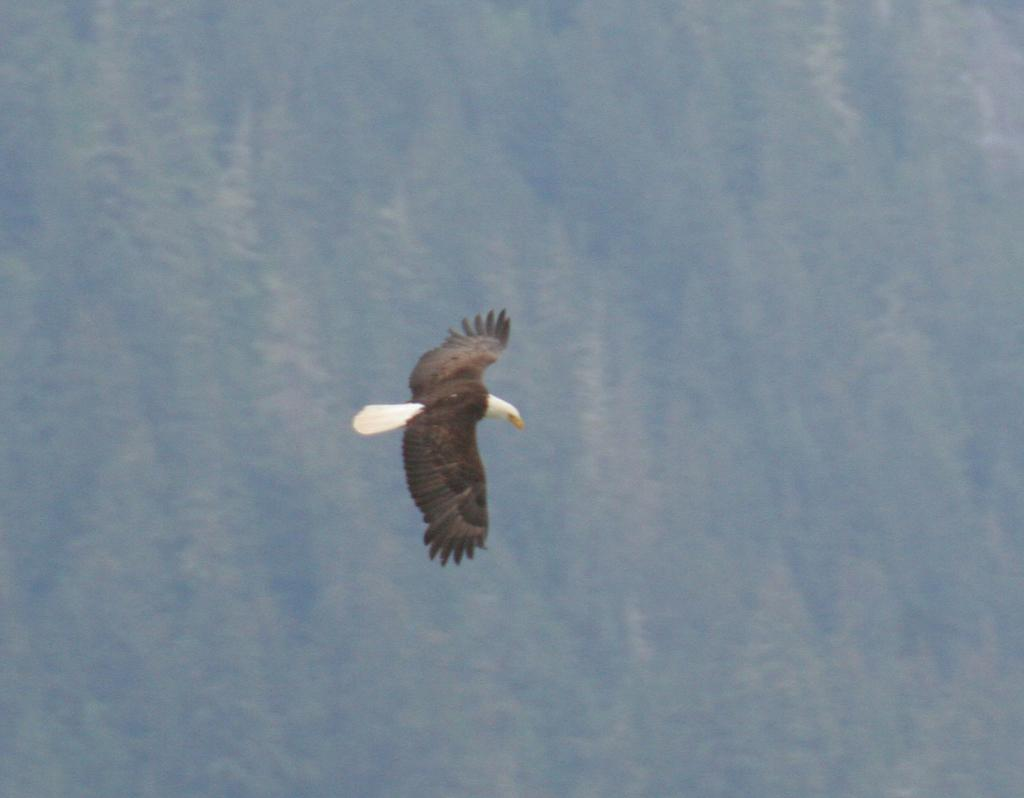What type of animal is present in the image? There is a bird in the image. What is the bird doing in the image? The bird is flying in the air. Can you describe the background of the image? The background of the image is blurred. What type of juice is being served under the umbrella in the image? There is no juice or umbrella present in the image; it features a bird flying in the air with a blurred background. 